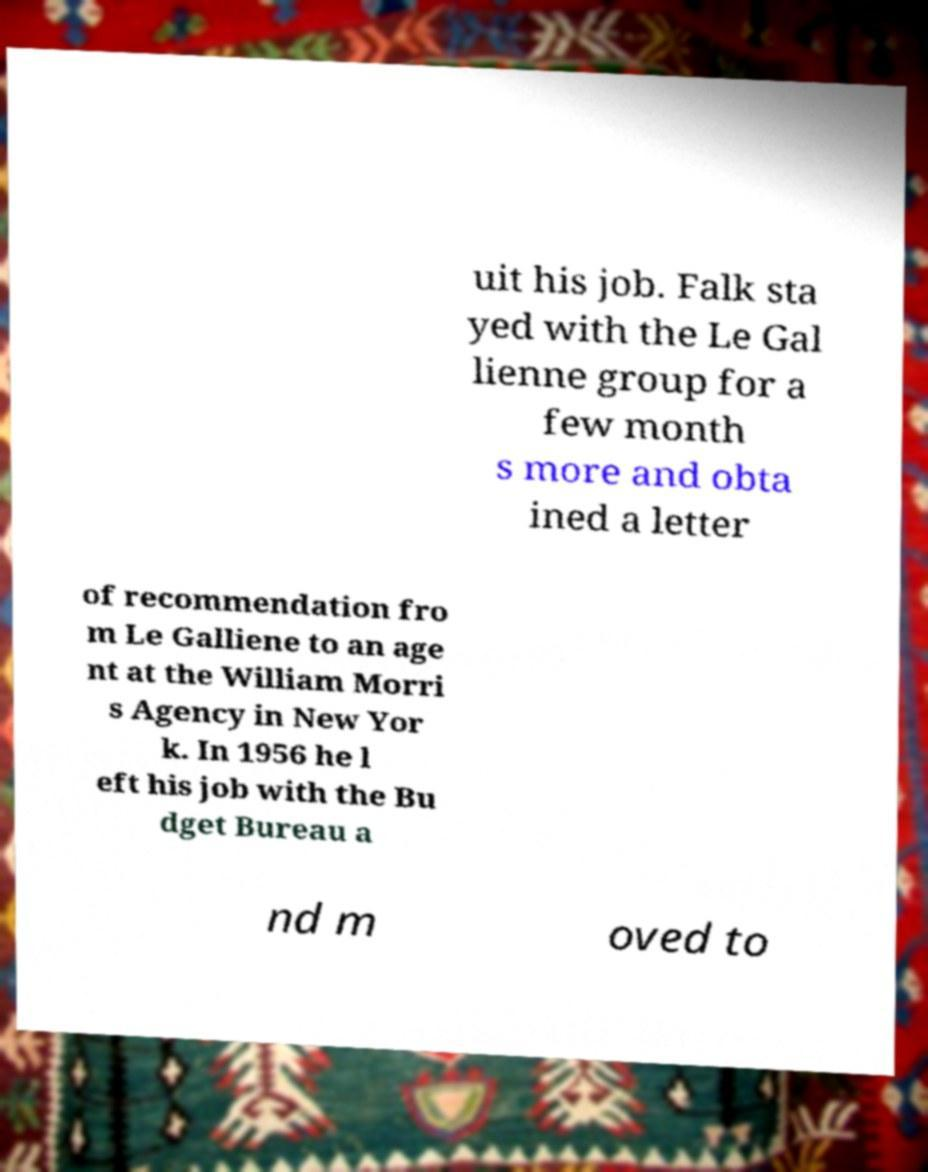There's text embedded in this image that I need extracted. Can you transcribe it verbatim? uit his job. Falk sta yed with the Le Gal lienne group for a few month s more and obta ined a letter of recommendation fro m Le Galliene to an age nt at the William Morri s Agency in New Yor k. In 1956 he l eft his job with the Bu dget Bureau a nd m oved to 